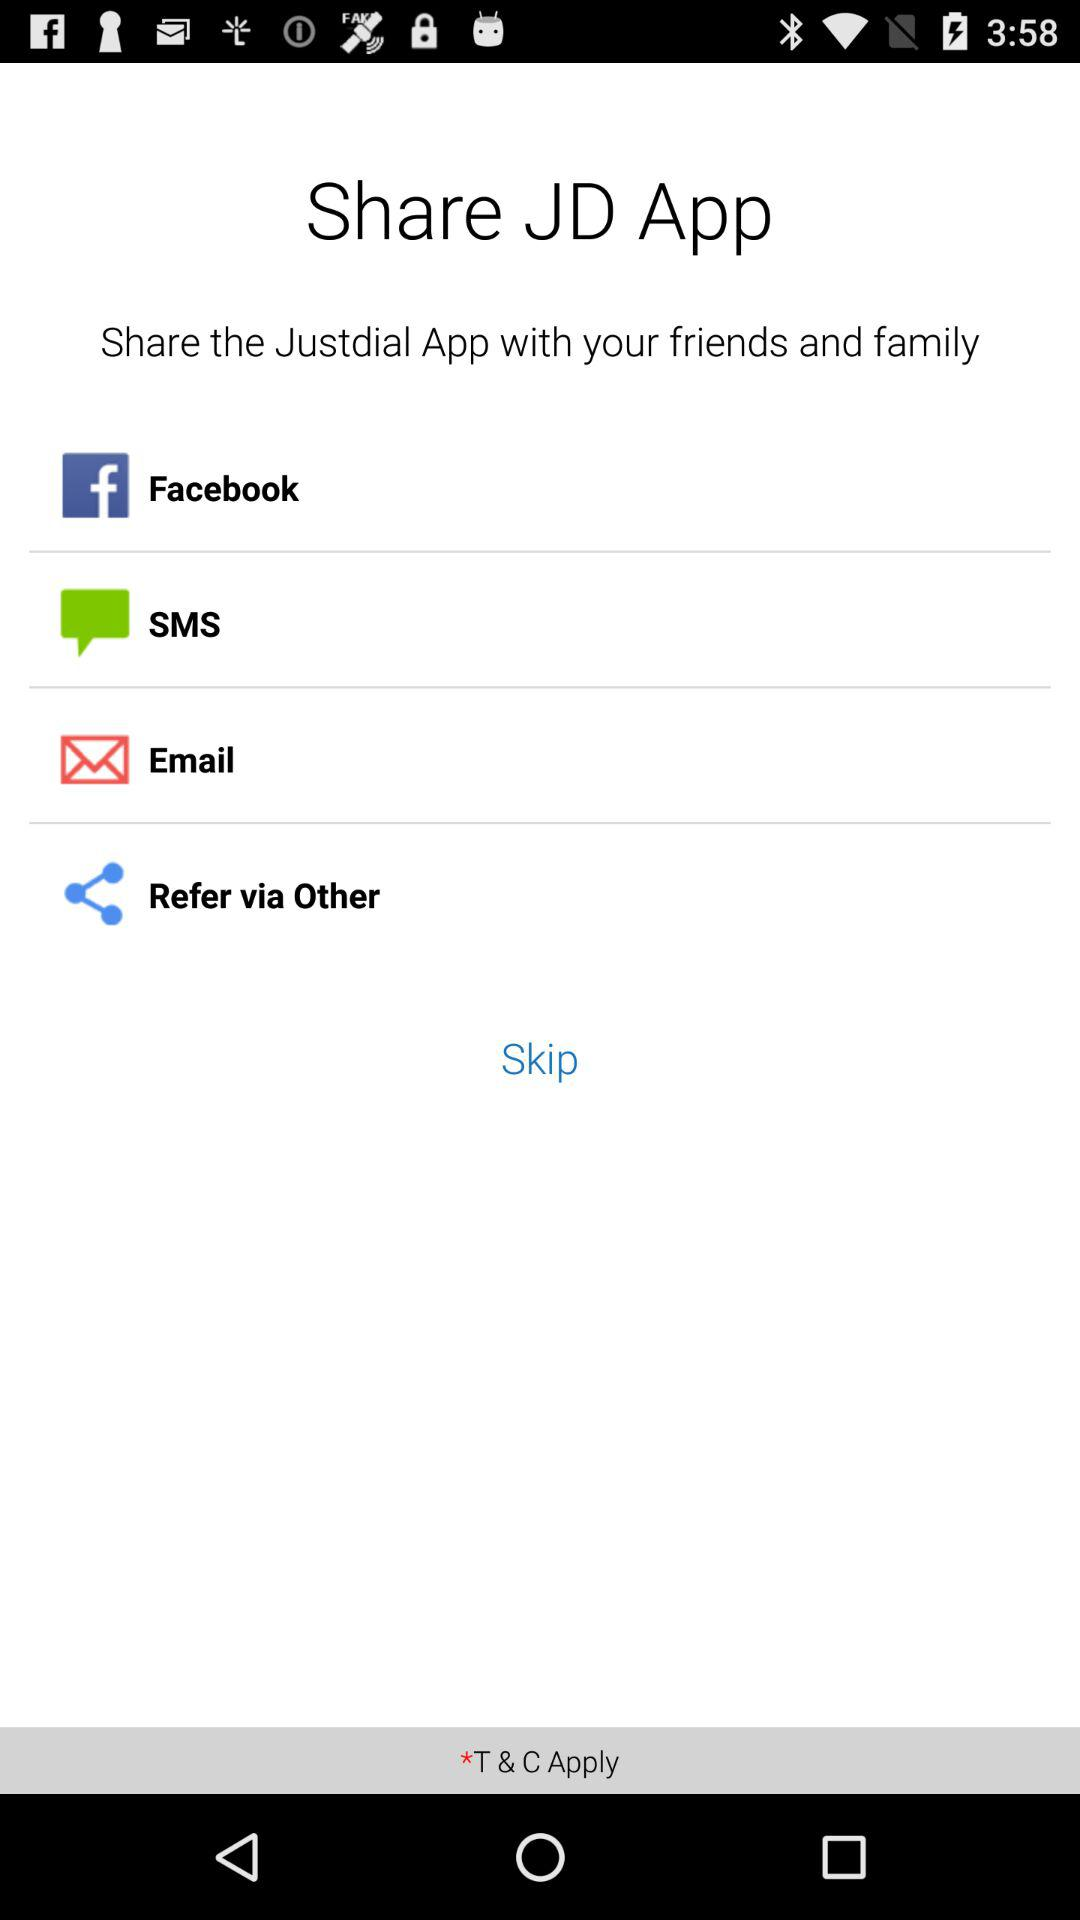How many ways are there to share the Justdial app?
Answer the question using a single word or phrase. 4 